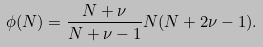<formula> <loc_0><loc_0><loc_500><loc_500>\phi ( N ) = \frac { N + \nu } { N + \nu - 1 } N ( N + 2 \nu - 1 ) .</formula> 